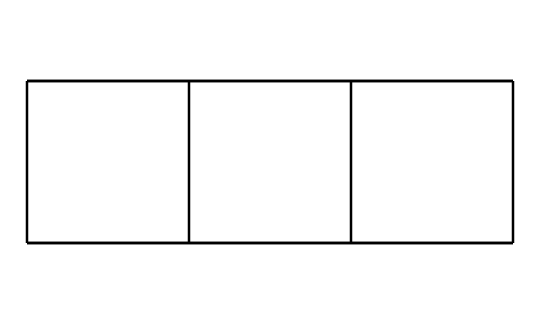What is the molecular formula of cubane? To determine the molecular formula, count the number of carbon (C) and hydrogen (H) atoms present in the structure. Cubane consists of 8 carbon atoms and 8 hydrogen atoms. Hence, the molecular formula is C8H8.
Answer: C8H8 How many carbon atoms are in cubane? By examining the chemical structure, we find that there are 8 vertices in the cube shape which correspond to 8 carbon atoms.
Answer: 8 What is the primary shape of cubane? Cubane has a distinct cube shape, characteristically making it a 3D representation that can be visualized in three dimensions.
Answer: cube What type of strain is present in cubane? The angle strain in cubane arises due to the bond angles deviating from the ideal tetrahedral angle of 109.5 degrees. The actual bond angles in cubane are approximately 90 degrees, leading to significant angle strain.
Answer: angle strain What unique property does cubane have regarding its application as fuel? Due to its highly strained structure, cubane has a high energy density, making it a potential candidate for use as a fuel source, as it can release a significant amount of energy upon combustion.
Answer: high energy density How does cubane’s structure affect its stability? The highly strained cubic configuration makes cubane less stable compared to other larger hydrocarbons. This instability leads to higher reactivity and a tendency to undergo decomposition.
Answer: less stable What classification does cubane belong to in organic chemistry? Cubane is classified as a saturated hydrocarbon, specifically a type of cage compound due to its unique three-dimensional structure resembling a cage.
Answer: cage compound 